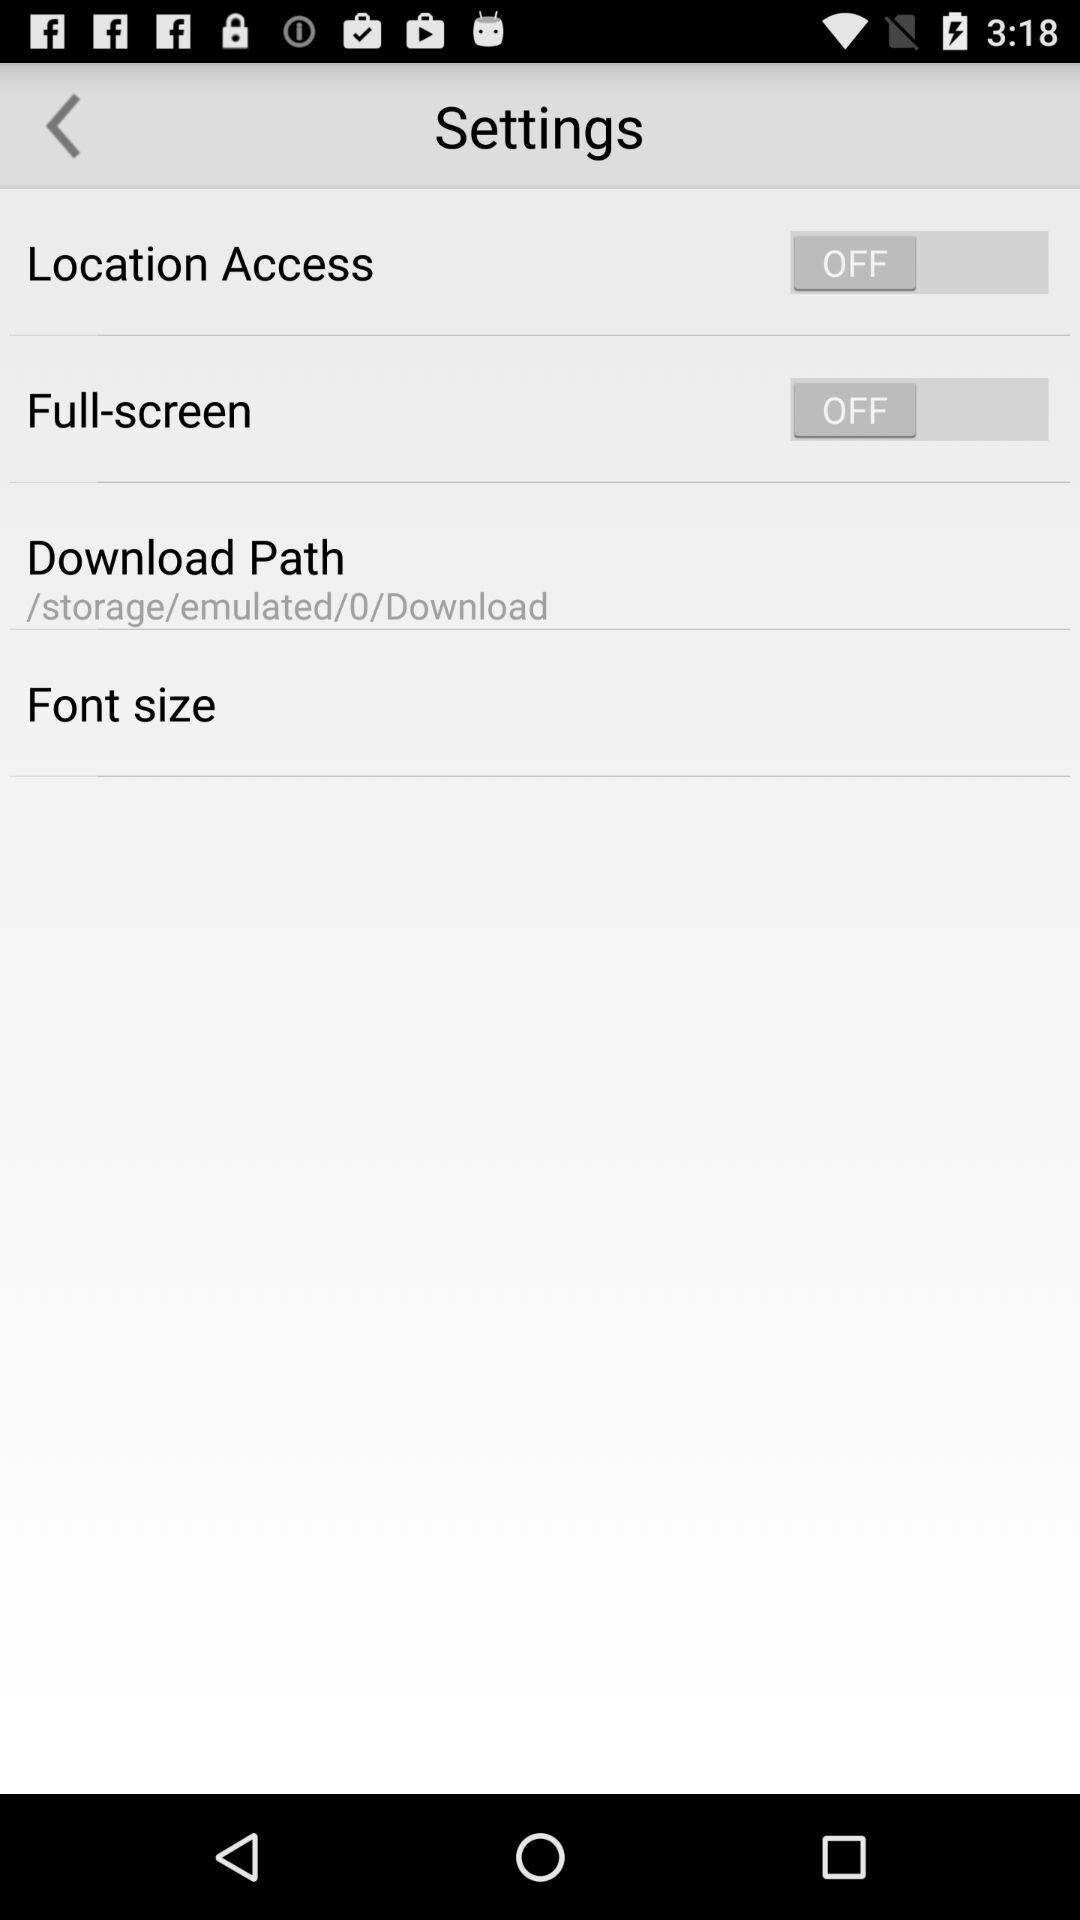What's the download path to download and save any file? The download path is "/storage/emulated/0/Download". 